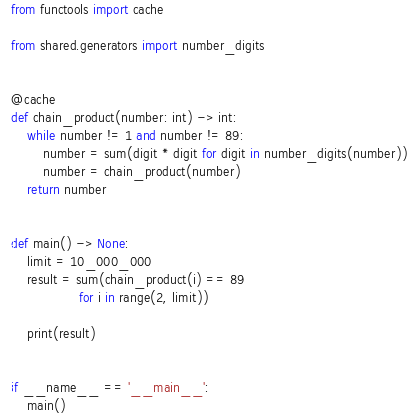Convert code to text. <code><loc_0><loc_0><loc_500><loc_500><_Python_>from functools import cache

from shared.generators import number_digits


@cache
def chain_product(number: int) -> int:
    while number != 1 and number != 89:
        number = sum(digit * digit for digit in number_digits(number))
        number = chain_product(number)
    return number


def main() -> None:
    limit = 10_000_000
    result = sum(chain_product(i) == 89
                 for i in range(2, limit))

    print(result)


if __name__ == '__main__':
    main()
</code> 